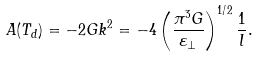Convert formula to latex. <formula><loc_0><loc_0><loc_500><loc_500>A ( T _ { d } ) = - 2 G k ^ { 2 } = - 4 \left ( \frac { \pi ^ { 3 } G } { \varepsilon _ { \perp } } \right ) ^ { 1 / 2 } \frac { 1 } { l } .</formula> 